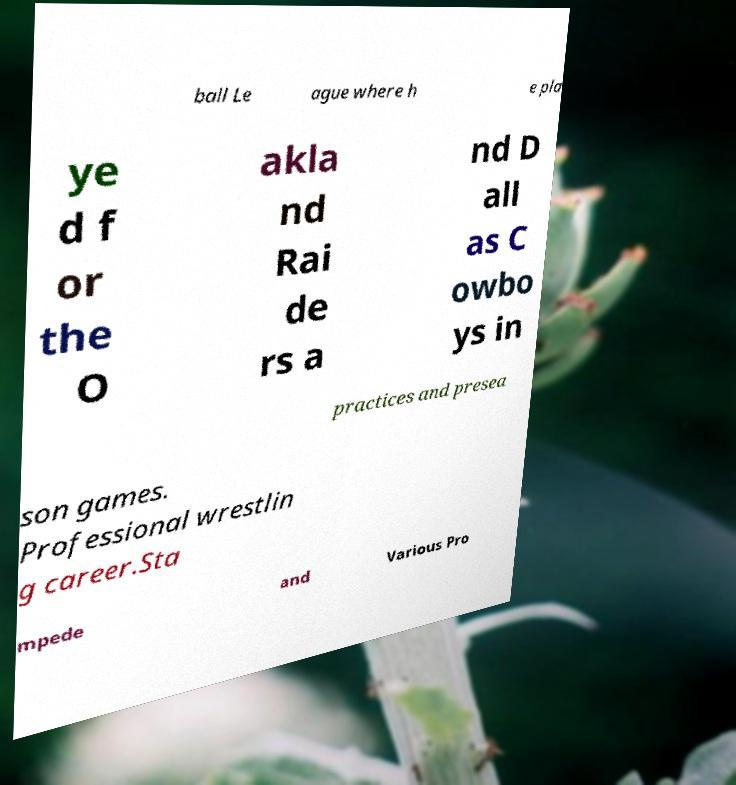Could you assist in decoding the text presented in this image and type it out clearly? ball Le ague where h e pla ye d f or the O akla nd Rai de rs a nd D all as C owbo ys in practices and presea son games. Professional wrestlin g career.Sta mpede and Various Pro 